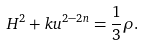<formula> <loc_0><loc_0><loc_500><loc_500>H ^ { 2 } + k u ^ { 2 - 2 n } = \frac { 1 } { 3 } \rho .</formula> 